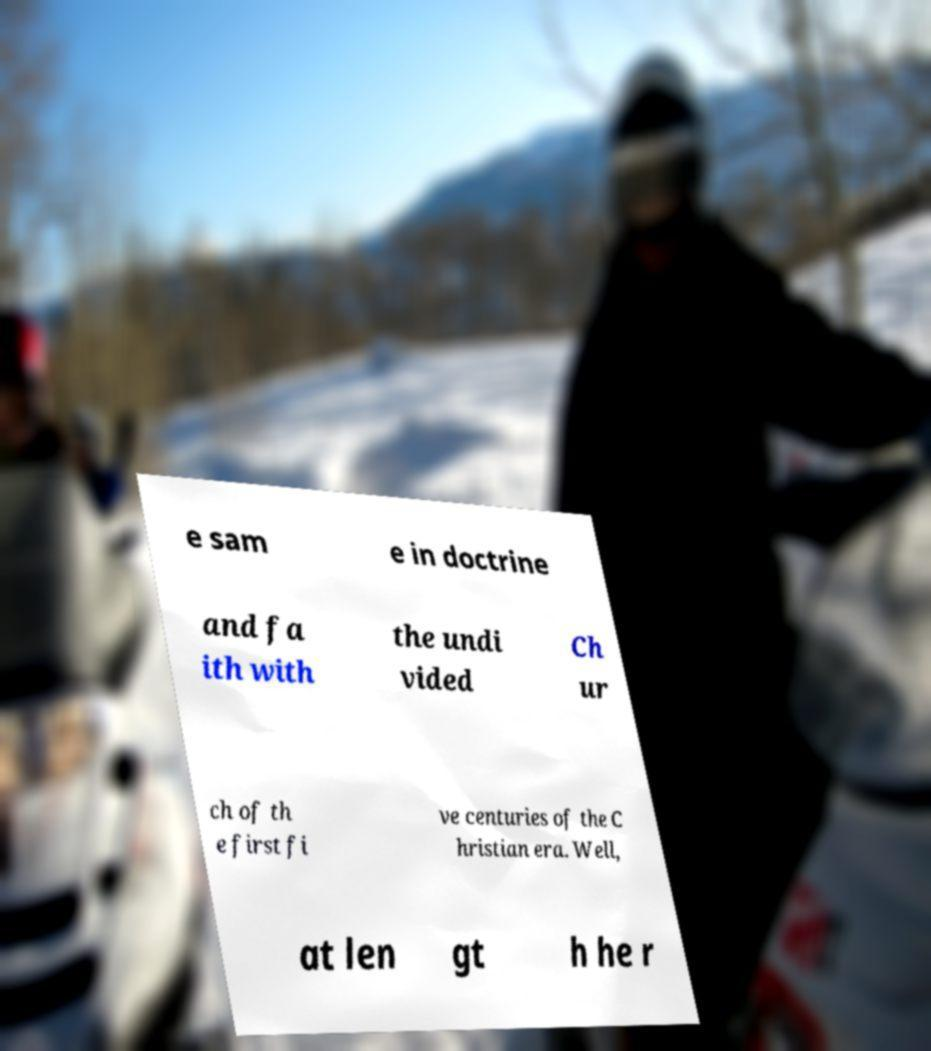I need the written content from this picture converted into text. Can you do that? e sam e in doctrine and fa ith with the undi vided Ch ur ch of th e first fi ve centuries of the C hristian era. Well, at len gt h he r 